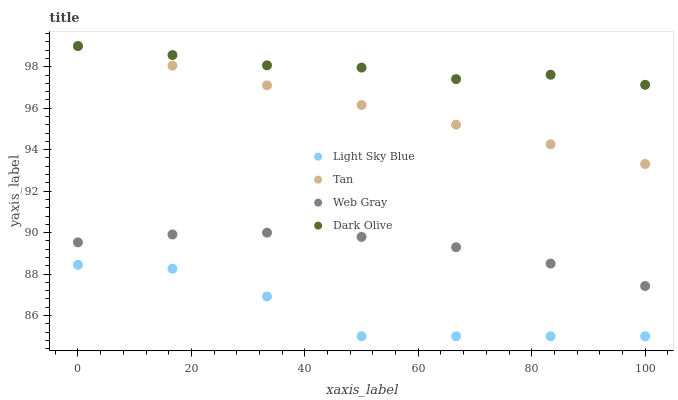Does Light Sky Blue have the minimum area under the curve?
Answer yes or no. Yes. Does Dark Olive have the maximum area under the curve?
Answer yes or no. Yes. Does Tan have the minimum area under the curve?
Answer yes or no. No. Does Tan have the maximum area under the curve?
Answer yes or no. No. Is Tan the smoothest?
Answer yes or no. Yes. Is Light Sky Blue the roughest?
Answer yes or no. Yes. Is Light Sky Blue the smoothest?
Answer yes or no. No. Is Tan the roughest?
Answer yes or no. No. Does Light Sky Blue have the lowest value?
Answer yes or no. Yes. Does Tan have the lowest value?
Answer yes or no. No. Does Tan have the highest value?
Answer yes or no. Yes. Does Light Sky Blue have the highest value?
Answer yes or no. No. Is Web Gray less than Dark Olive?
Answer yes or no. Yes. Is Tan greater than Web Gray?
Answer yes or no. Yes. Does Dark Olive intersect Tan?
Answer yes or no. Yes. Is Dark Olive less than Tan?
Answer yes or no. No. Is Dark Olive greater than Tan?
Answer yes or no. No. Does Web Gray intersect Dark Olive?
Answer yes or no. No. 